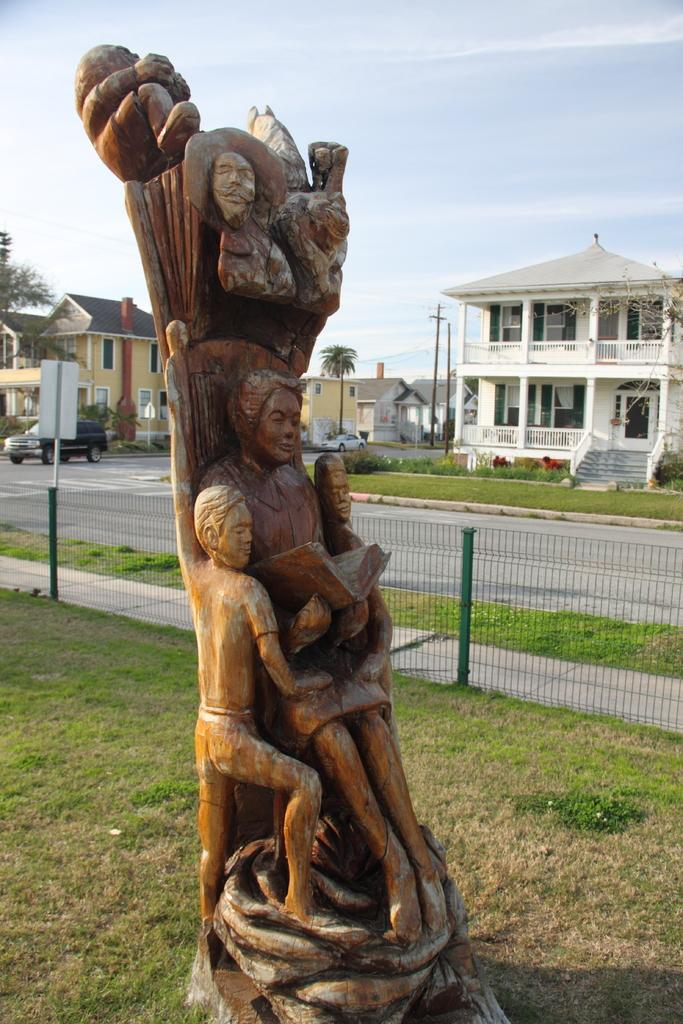What is the main subject of the wooden sculpture in the image? The wooden sculpture in the image depicts people. What type of barrier can be seen in the image? There is a fence in the image. What type of vegetation is present in the image? There is grass in the image. What type of transportation can be seen in the image? There are vehicles on the road in the image. What type of structures are visible in the background of the image? There are houses in the background of the image. What other types of vegetation can be seen in the background of the image? There are trees and plants in the background of the image. What part of the natural environment is visible in the background of the image? The sky is visible in the background of the image. What type of vase is visible on the fence in the image? There is no vase present on the fence in the image. Can you describe the stranger walking through the grass in the image? There is no stranger present in the image; it only features a wooden sculpture, a fence, grass, vehicles, houses, trees, plants, and the sky. 